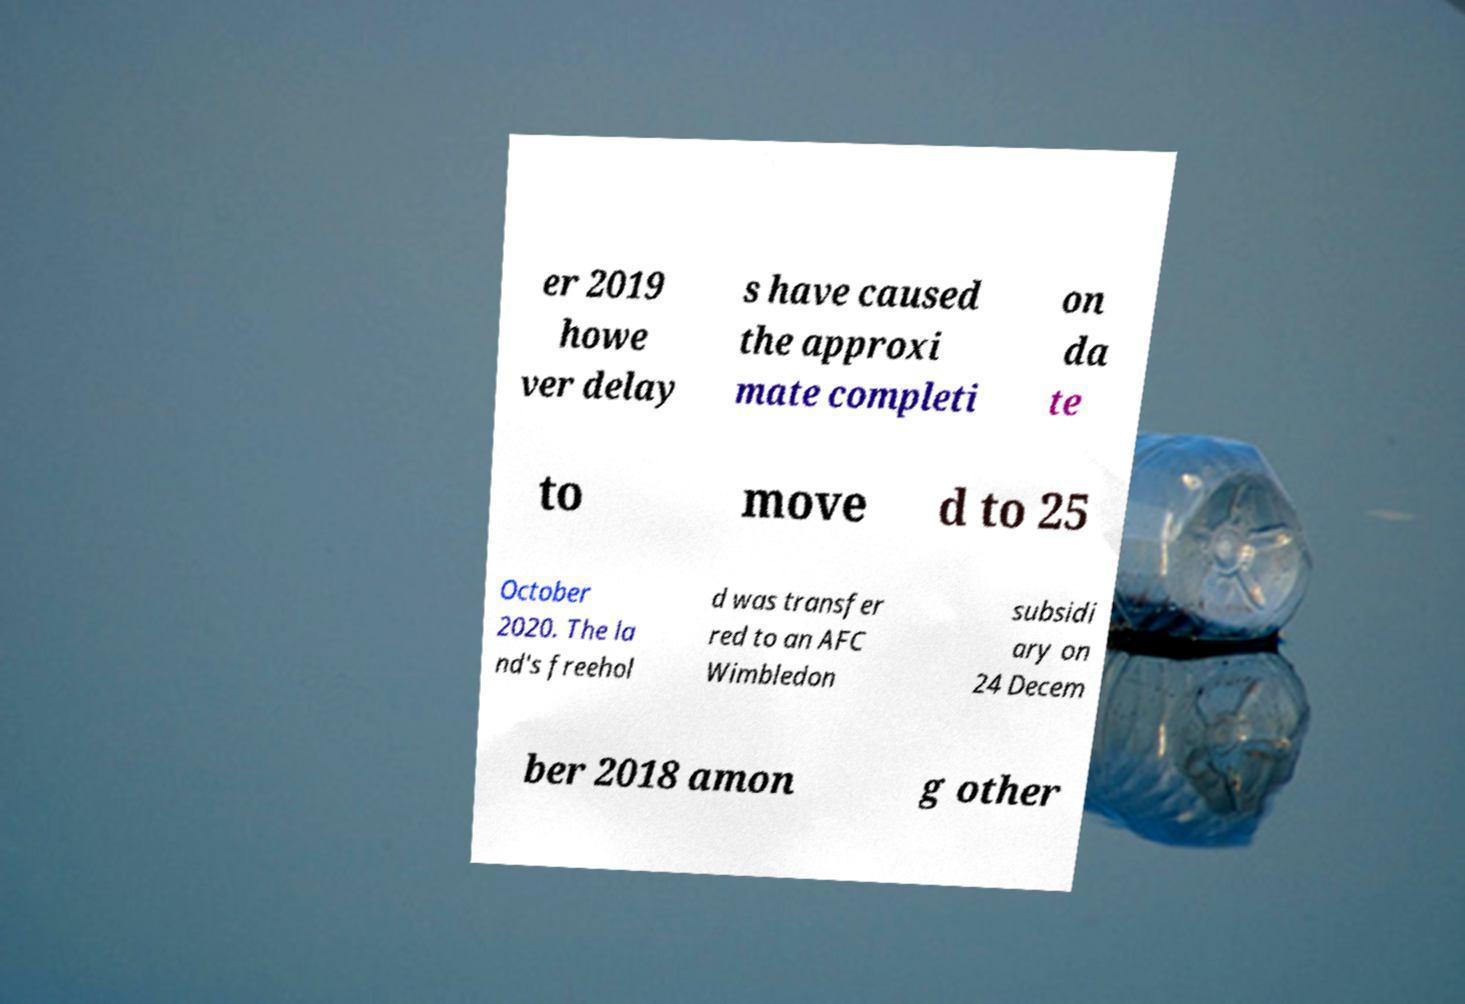Please identify and transcribe the text found in this image. er 2019 howe ver delay s have caused the approxi mate completi on da te to move d to 25 October 2020. The la nd's freehol d was transfer red to an AFC Wimbledon subsidi ary on 24 Decem ber 2018 amon g other 